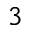<formula> <loc_0><loc_0><loc_500><loc_500>3</formula> 